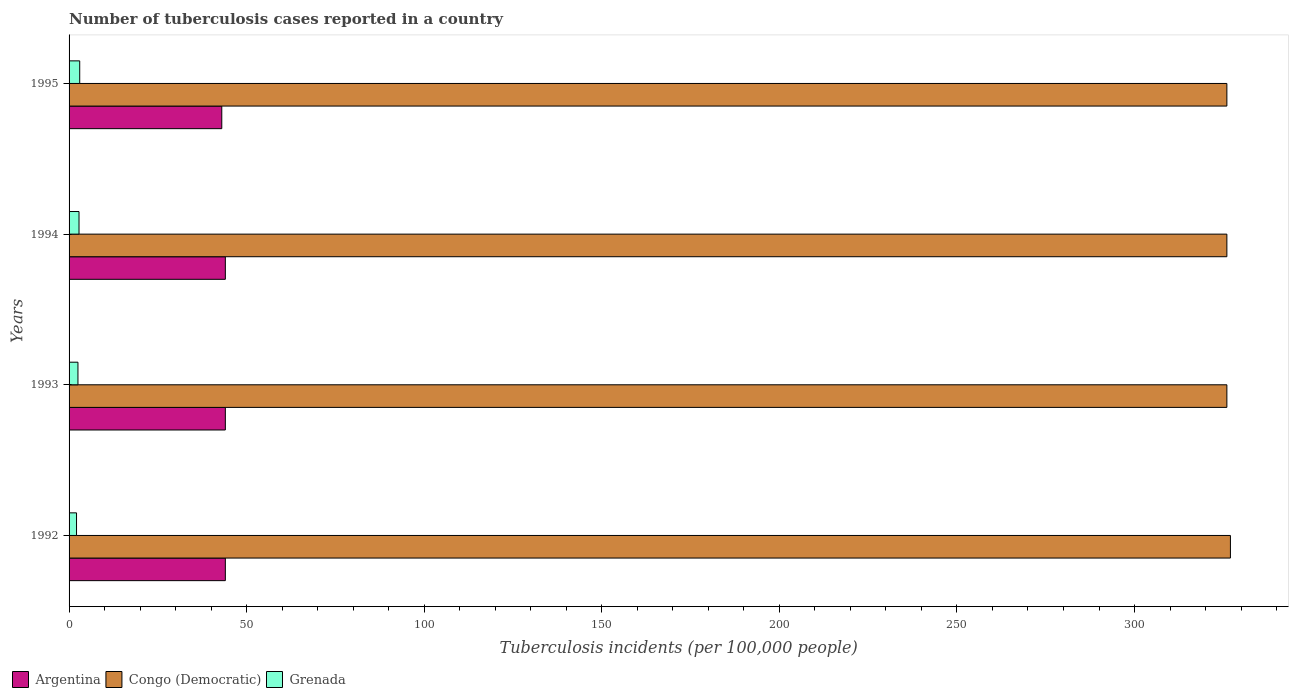How many different coloured bars are there?
Keep it short and to the point. 3. Are the number of bars per tick equal to the number of legend labels?
Keep it short and to the point. Yes. Are the number of bars on each tick of the Y-axis equal?
Offer a very short reply. Yes. How many bars are there on the 1st tick from the bottom?
Provide a short and direct response. 3. In how many cases, is the number of bars for a given year not equal to the number of legend labels?
Provide a short and direct response. 0. What is the number of tuberculosis cases reported in in Argentina in 1993?
Provide a short and direct response. 44. Across all years, what is the minimum number of tuberculosis cases reported in in Argentina?
Ensure brevity in your answer.  43. In which year was the number of tuberculosis cases reported in in Argentina maximum?
Offer a very short reply. 1992. What is the total number of tuberculosis cases reported in in Grenada in the graph?
Ensure brevity in your answer.  10.4. What is the difference between the number of tuberculosis cases reported in in Congo (Democratic) in 1992 and the number of tuberculosis cases reported in in Argentina in 1993?
Provide a succinct answer. 283. What is the average number of tuberculosis cases reported in in Grenada per year?
Your response must be concise. 2.6. In the year 1993, what is the difference between the number of tuberculosis cases reported in in Grenada and number of tuberculosis cases reported in in Congo (Democratic)?
Ensure brevity in your answer.  -323.5. In how many years, is the number of tuberculosis cases reported in in Grenada greater than 20 ?
Offer a terse response. 0. What is the ratio of the number of tuberculosis cases reported in in Grenada in 1993 to that in 1995?
Keep it short and to the point. 0.83. Is the number of tuberculosis cases reported in in Argentina in 1993 less than that in 1995?
Your answer should be very brief. No. Is the difference between the number of tuberculosis cases reported in in Grenada in 1992 and 1994 greater than the difference between the number of tuberculosis cases reported in in Congo (Democratic) in 1992 and 1994?
Give a very brief answer. No. What is the difference between the highest and the second highest number of tuberculosis cases reported in in Grenada?
Give a very brief answer. 0.2. What is the difference between the highest and the lowest number of tuberculosis cases reported in in Congo (Democratic)?
Provide a short and direct response. 1. In how many years, is the number of tuberculosis cases reported in in Argentina greater than the average number of tuberculosis cases reported in in Argentina taken over all years?
Provide a succinct answer. 3. Is the sum of the number of tuberculosis cases reported in in Grenada in 1993 and 1995 greater than the maximum number of tuberculosis cases reported in in Congo (Democratic) across all years?
Ensure brevity in your answer.  No. What does the 3rd bar from the top in 1993 represents?
Make the answer very short. Argentina. What does the 3rd bar from the bottom in 1993 represents?
Your answer should be very brief. Grenada. What is the difference between two consecutive major ticks on the X-axis?
Ensure brevity in your answer.  50. Are the values on the major ticks of X-axis written in scientific E-notation?
Offer a very short reply. No. How many legend labels are there?
Give a very brief answer. 3. How are the legend labels stacked?
Offer a very short reply. Horizontal. What is the title of the graph?
Provide a short and direct response. Number of tuberculosis cases reported in a country. Does "Gabon" appear as one of the legend labels in the graph?
Provide a short and direct response. No. What is the label or title of the X-axis?
Your response must be concise. Tuberculosis incidents (per 100,0 people). What is the Tuberculosis incidents (per 100,000 people) of Congo (Democratic) in 1992?
Ensure brevity in your answer.  327. What is the Tuberculosis incidents (per 100,000 people) in Argentina in 1993?
Offer a terse response. 44. What is the Tuberculosis incidents (per 100,000 people) in Congo (Democratic) in 1993?
Provide a succinct answer. 326. What is the Tuberculosis incidents (per 100,000 people) in Congo (Democratic) in 1994?
Give a very brief answer. 326. What is the Tuberculosis incidents (per 100,000 people) of Grenada in 1994?
Offer a terse response. 2.8. What is the Tuberculosis incidents (per 100,000 people) in Argentina in 1995?
Offer a very short reply. 43. What is the Tuberculosis incidents (per 100,000 people) of Congo (Democratic) in 1995?
Your answer should be very brief. 326. Across all years, what is the maximum Tuberculosis incidents (per 100,000 people) of Argentina?
Give a very brief answer. 44. Across all years, what is the maximum Tuberculosis incidents (per 100,000 people) of Congo (Democratic)?
Offer a very short reply. 327. Across all years, what is the maximum Tuberculosis incidents (per 100,000 people) of Grenada?
Your answer should be compact. 3. Across all years, what is the minimum Tuberculosis incidents (per 100,000 people) of Argentina?
Your answer should be compact. 43. Across all years, what is the minimum Tuberculosis incidents (per 100,000 people) of Congo (Democratic)?
Keep it short and to the point. 326. What is the total Tuberculosis incidents (per 100,000 people) in Argentina in the graph?
Make the answer very short. 175. What is the total Tuberculosis incidents (per 100,000 people) in Congo (Democratic) in the graph?
Provide a succinct answer. 1305. What is the total Tuberculosis incidents (per 100,000 people) in Grenada in the graph?
Give a very brief answer. 10.4. What is the difference between the Tuberculosis incidents (per 100,000 people) of Congo (Democratic) in 1992 and that in 1993?
Give a very brief answer. 1. What is the difference between the Tuberculosis incidents (per 100,000 people) of Grenada in 1992 and that in 1993?
Provide a succinct answer. -0.4. What is the difference between the Tuberculosis incidents (per 100,000 people) in Congo (Democratic) in 1992 and that in 1994?
Your answer should be very brief. 1. What is the difference between the Tuberculosis incidents (per 100,000 people) in Grenada in 1992 and that in 1994?
Give a very brief answer. -0.7. What is the difference between the Tuberculosis incidents (per 100,000 people) in Argentina in 1992 and that in 1995?
Offer a very short reply. 1. What is the difference between the Tuberculosis incidents (per 100,000 people) of Grenada in 1993 and that in 1995?
Your answer should be very brief. -0.5. What is the difference between the Tuberculosis incidents (per 100,000 people) in Argentina in 1994 and that in 1995?
Give a very brief answer. 1. What is the difference between the Tuberculosis incidents (per 100,000 people) of Congo (Democratic) in 1994 and that in 1995?
Ensure brevity in your answer.  0. What is the difference between the Tuberculosis incidents (per 100,000 people) of Grenada in 1994 and that in 1995?
Give a very brief answer. -0.2. What is the difference between the Tuberculosis incidents (per 100,000 people) in Argentina in 1992 and the Tuberculosis incidents (per 100,000 people) in Congo (Democratic) in 1993?
Make the answer very short. -282. What is the difference between the Tuberculosis incidents (per 100,000 people) of Argentina in 1992 and the Tuberculosis incidents (per 100,000 people) of Grenada in 1993?
Make the answer very short. 41.5. What is the difference between the Tuberculosis incidents (per 100,000 people) of Congo (Democratic) in 1992 and the Tuberculosis incidents (per 100,000 people) of Grenada in 1993?
Give a very brief answer. 324.5. What is the difference between the Tuberculosis incidents (per 100,000 people) in Argentina in 1992 and the Tuberculosis incidents (per 100,000 people) in Congo (Democratic) in 1994?
Keep it short and to the point. -282. What is the difference between the Tuberculosis incidents (per 100,000 people) of Argentina in 1992 and the Tuberculosis incidents (per 100,000 people) of Grenada in 1994?
Provide a short and direct response. 41.2. What is the difference between the Tuberculosis incidents (per 100,000 people) in Congo (Democratic) in 1992 and the Tuberculosis incidents (per 100,000 people) in Grenada in 1994?
Keep it short and to the point. 324.2. What is the difference between the Tuberculosis incidents (per 100,000 people) of Argentina in 1992 and the Tuberculosis incidents (per 100,000 people) of Congo (Democratic) in 1995?
Your answer should be compact. -282. What is the difference between the Tuberculosis incidents (per 100,000 people) in Congo (Democratic) in 1992 and the Tuberculosis incidents (per 100,000 people) in Grenada in 1995?
Give a very brief answer. 324. What is the difference between the Tuberculosis incidents (per 100,000 people) in Argentina in 1993 and the Tuberculosis incidents (per 100,000 people) in Congo (Democratic) in 1994?
Give a very brief answer. -282. What is the difference between the Tuberculosis incidents (per 100,000 people) in Argentina in 1993 and the Tuberculosis incidents (per 100,000 people) in Grenada in 1994?
Your answer should be very brief. 41.2. What is the difference between the Tuberculosis incidents (per 100,000 people) of Congo (Democratic) in 1993 and the Tuberculosis incidents (per 100,000 people) of Grenada in 1994?
Your answer should be very brief. 323.2. What is the difference between the Tuberculosis incidents (per 100,000 people) in Argentina in 1993 and the Tuberculosis incidents (per 100,000 people) in Congo (Democratic) in 1995?
Your answer should be very brief. -282. What is the difference between the Tuberculosis incidents (per 100,000 people) of Congo (Democratic) in 1993 and the Tuberculosis incidents (per 100,000 people) of Grenada in 1995?
Offer a very short reply. 323. What is the difference between the Tuberculosis incidents (per 100,000 people) of Argentina in 1994 and the Tuberculosis incidents (per 100,000 people) of Congo (Democratic) in 1995?
Give a very brief answer. -282. What is the difference between the Tuberculosis incidents (per 100,000 people) in Argentina in 1994 and the Tuberculosis incidents (per 100,000 people) in Grenada in 1995?
Make the answer very short. 41. What is the difference between the Tuberculosis incidents (per 100,000 people) in Congo (Democratic) in 1994 and the Tuberculosis incidents (per 100,000 people) in Grenada in 1995?
Give a very brief answer. 323. What is the average Tuberculosis incidents (per 100,000 people) of Argentina per year?
Make the answer very short. 43.75. What is the average Tuberculosis incidents (per 100,000 people) of Congo (Democratic) per year?
Offer a terse response. 326.25. In the year 1992, what is the difference between the Tuberculosis incidents (per 100,000 people) in Argentina and Tuberculosis incidents (per 100,000 people) in Congo (Democratic)?
Your answer should be compact. -283. In the year 1992, what is the difference between the Tuberculosis incidents (per 100,000 people) of Argentina and Tuberculosis incidents (per 100,000 people) of Grenada?
Your answer should be compact. 41.9. In the year 1992, what is the difference between the Tuberculosis incidents (per 100,000 people) of Congo (Democratic) and Tuberculosis incidents (per 100,000 people) of Grenada?
Your response must be concise. 324.9. In the year 1993, what is the difference between the Tuberculosis incidents (per 100,000 people) in Argentina and Tuberculosis incidents (per 100,000 people) in Congo (Democratic)?
Provide a short and direct response. -282. In the year 1993, what is the difference between the Tuberculosis incidents (per 100,000 people) of Argentina and Tuberculosis incidents (per 100,000 people) of Grenada?
Provide a succinct answer. 41.5. In the year 1993, what is the difference between the Tuberculosis incidents (per 100,000 people) in Congo (Democratic) and Tuberculosis incidents (per 100,000 people) in Grenada?
Provide a succinct answer. 323.5. In the year 1994, what is the difference between the Tuberculosis incidents (per 100,000 people) in Argentina and Tuberculosis incidents (per 100,000 people) in Congo (Democratic)?
Your response must be concise. -282. In the year 1994, what is the difference between the Tuberculosis incidents (per 100,000 people) of Argentina and Tuberculosis incidents (per 100,000 people) of Grenada?
Provide a short and direct response. 41.2. In the year 1994, what is the difference between the Tuberculosis incidents (per 100,000 people) in Congo (Democratic) and Tuberculosis incidents (per 100,000 people) in Grenada?
Your answer should be very brief. 323.2. In the year 1995, what is the difference between the Tuberculosis incidents (per 100,000 people) of Argentina and Tuberculosis incidents (per 100,000 people) of Congo (Democratic)?
Provide a succinct answer. -283. In the year 1995, what is the difference between the Tuberculosis incidents (per 100,000 people) of Congo (Democratic) and Tuberculosis incidents (per 100,000 people) of Grenada?
Ensure brevity in your answer.  323. What is the ratio of the Tuberculosis incidents (per 100,000 people) of Argentina in 1992 to that in 1993?
Your answer should be very brief. 1. What is the ratio of the Tuberculosis incidents (per 100,000 people) in Grenada in 1992 to that in 1993?
Give a very brief answer. 0.84. What is the ratio of the Tuberculosis incidents (per 100,000 people) in Argentina in 1992 to that in 1994?
Offer a terse response. 1. What is the ratio of the Tuberculosis incidents (per 100,000 people) in Grenada in 1992 to that in 1994?
Your answer should be very brief. 0.75. What is the ratio of the Tuberculosis incidents (per 100,000 people) of Argentina in 1992 to that in 1995?
Give a very brief answer. 1.02. What is the ratio of the Tuberculosis incidents (per 100,000 people) in Argentina in 1993 to that in 1994?
Your response must be concise. 1. What is the ratio of the Tuberculosis incidents (per 100,000 people) of Grenada in 1993 to that in 1994?
Offer a terse response. 0.89. What is the ratio of the Tuberculosis incidents (per 100,000 people) in Argentina in 1993 to that in 1995?
Your answer should be very brief. 1.02. What is the ratio of the Tuberculosis incidents (per 100,000 people) of Congo (Democratic) in 1993 to that in 1995?
Your response must be concise. 1. What is the ratio of the Tuberculosis incidents (per 100,000 people) in Grenada in 1993 to that in 1995?
Provide a short and direct response. 0.83. What is the ratio of the Tuberculosis incidents (per 100,000 people) of Argentina in 1994 to that in 1995?
Your response must be concise. 1.02. What is the ratio of the Tuberculosis incidents (per 100,000 people) of Congo (Democratic) in 1994 to that in 1995?
Your answer should be compact. 1. What is the ratio of the Tuberculosis incidents (per 100,000 people) in Grenada in 1994 to that in 1995?
Ensure brevity in your answer.  0.93. What is the difference between the highest and the second highest Tuberculosis incidents (per 100,000 people) of Argentina?
Keep it short and to the point. 0. What is the difference between the highest and the second highest Tuberculosis incidents (per 100,000 people) of Grenada?
Your answer should be compact. 0.2. What is the difference between the highest and the lowest Tuberculosis incidents (per 100,000 people) in Argentina?
Keep it short and to the point. 1. What is the difference between the highest and the lowest Tuberculosis incidents (per 100,000 people) of Congo (Democratic)?
Keep it short and to the point. 1. 